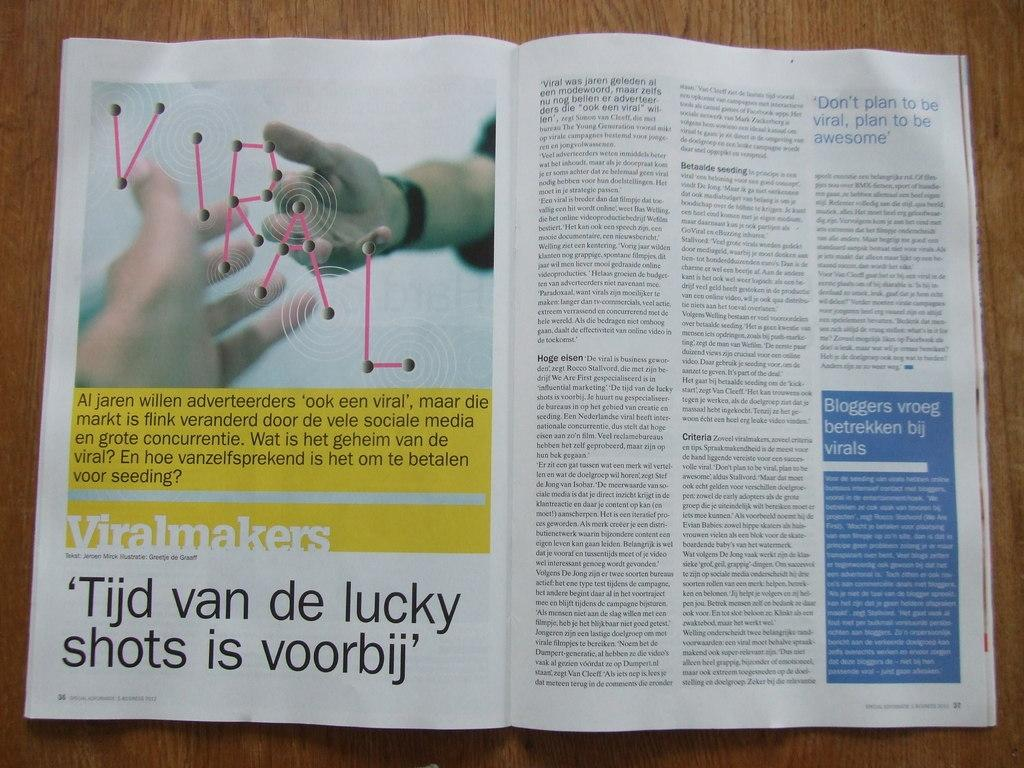<image>
Provide a brief description of the given image. A page out of a magazine written in a foreign language 